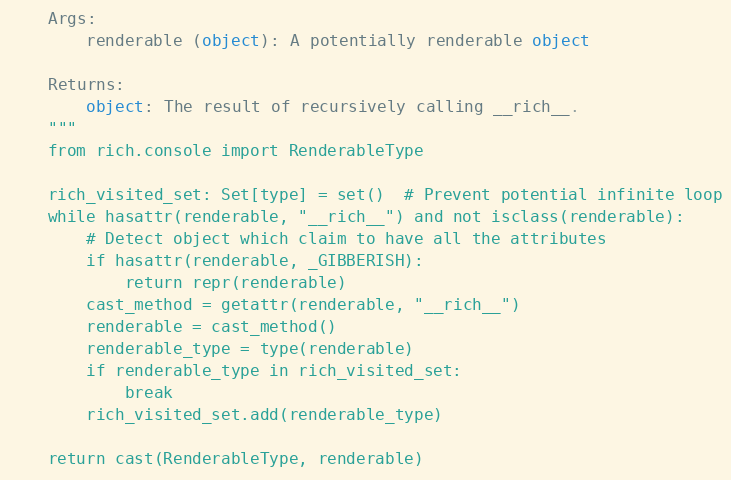<code> <loc_0><loc_0><loc_500><loc_500><_Python_>
    Args:
        renderable (object): A potentially renderable object

    Returns:
        object: The result of recursively calling __rich__.
    """
    from rich.console import RenderableType

    rich_visited_set: Set[type] = set()  # Prevent potential infinite loop
    while hasattr(renderable, "__rich__") and not isclass(renderable):
        # Detect object which claim to have all the attributes
        if hasattr(renderable, _GIBBERISH):
            return repr(renderable)
        cast_method = getattr(renderable, "__rich__")
        renderable = cast_method()
        renderable_type = type(renderable)
        if renderable_type in rich_visited_set:
            break
        rich_visited_set.add(renderable_type)

    return cast(RenderableType, renderable)
</code> 